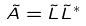<formula> <loc_0><loc_0><loc_500><loc_500>\tilde { A } = \tilde { L } \tilde { L } ^ { * }</formula> 